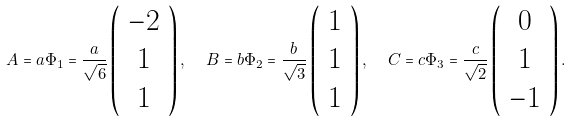<formula> <loc_0><loc_0><loc_500><loc_500>A = a \Phi _ { 1 } = \frac { a } { \sqrt { 6 } } \left ( \begin{array} { c } - 2 \\ 1 \\ 1 \end{array} \right ) , \ \ B = b \Phi _ { 2 } = \frac { b } { \sqrt { 3 } } \left ( \begin{array} { c } 1 \\ 1 \\ 1 \end{array} \right ) , \ \ C = c \Phi _ { 3 } = \frac { c } { \sqrt { 2 } } \left ( \begin{array} { c } 0 \\ 1 \\ - 1 \end{array} \right ) .</formula> 